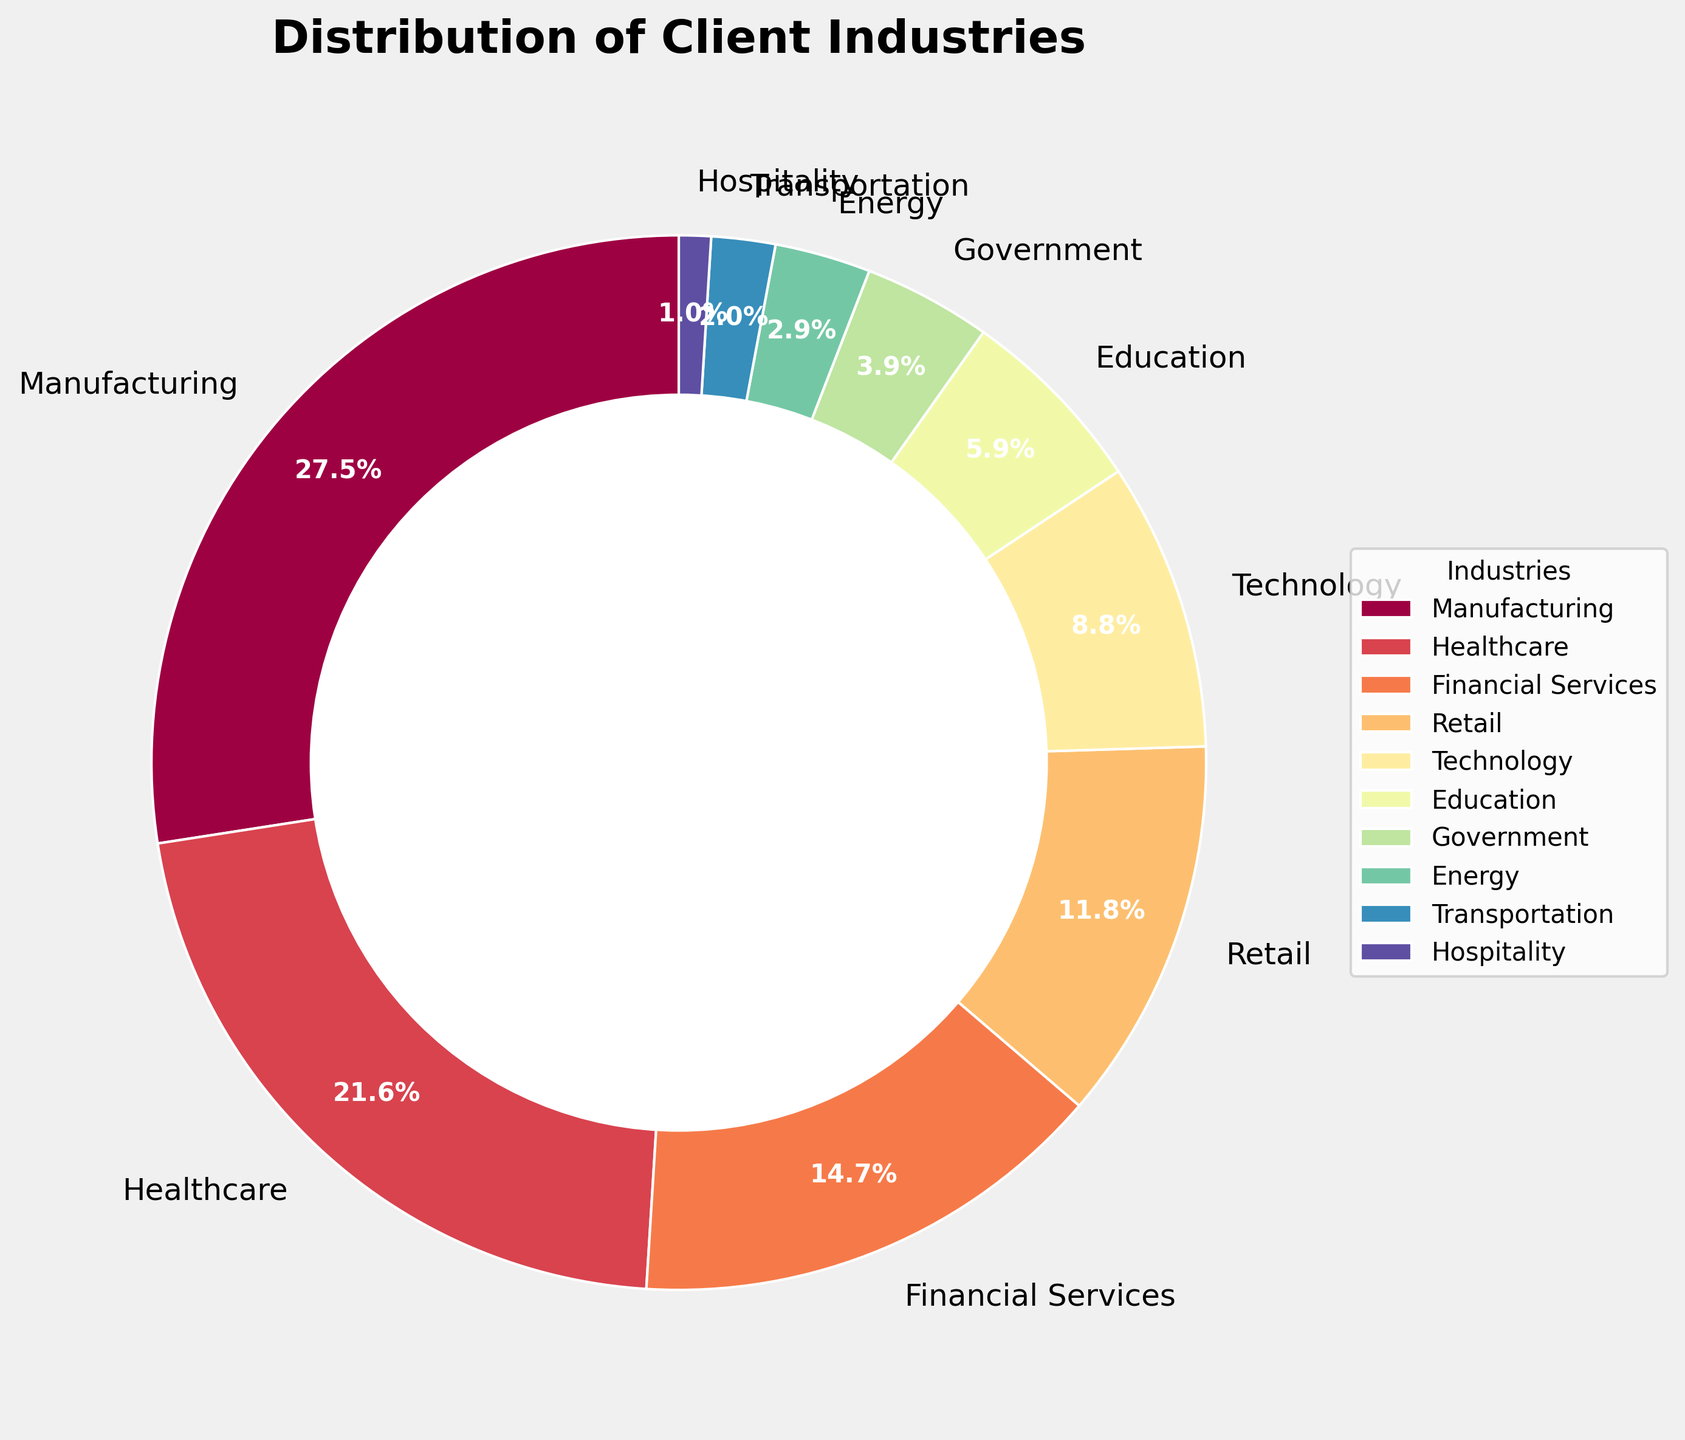What percentage of our clients come from the Manufacturing and Healthcare industries combined? To find the combined percentage of clients from Manufacturing and Healthcare, add their individual percentages: Manufacturing (28%) + Healthcare (22%) = 50%.
Answer: 50% Which industry serves a larger percentage of clients, Financial Services or Retail? Compare the percentages of clients from Financial Services (15%) and Retail (12%). Financial Services serves a larger percentage.
Answer: Financial Services What is the difference in the client percentage between Technology and Education industries? Subtract the percentage of clients in the Education industry (6%) from the Technology industry (9%): 9% - 6% = 3%.
Answer: 3% What is the percentage of clients served by the three smallest industries? Sum the percentages of the three smallest industries: Hospitality (1%) + Transportation (2%) + Energy (3%) = 6%.
Answer: 6% Which industry serves one-fifth of the clients compared to Manufacturing? One-fifth of Manufacturing's percentage (28%) is 28% / 5 = 5.6%. Education, with 6%, is closest to serving one-fifth of the Manufacturing clients.
Answer: Education What percentage of clients is served by non-manufacturing industries? Subtract Manufacturing's percentage (28%) from the total percentage (100%): 100% - 28% = 72%.
Answer: 72% Which industry has a smaller client percentage, Government or Technology? Compare the percentages of the Government (4%) and Technology (9%) industries. Government has a smaller client percentage.
Answer: Government What percentage of clients do the top four industries (by percentage) serve? Sum the percentages of the top four industries: Manufacturing (28%) + Healthcare (22%) + Financial Services (15%) + Retail (12%) = 77%.
Answer: 77% What is the average percentage of clients served by all industries except the largest one? Exclude the largest industry (Manufacturing, 28%) and sum the remaining percentages: Healthcare (22%) + Financial Services (15%) + Retail (12%) + Technology (9%) + Education (6%) + Government (4%) + Energy (3%) + Transportation (2%) + Hospitality (1%) = 74%. Divide by the number of industries (9): 74% / 9 ≈ 8.2%.
Answer: ≈ 8.2% 